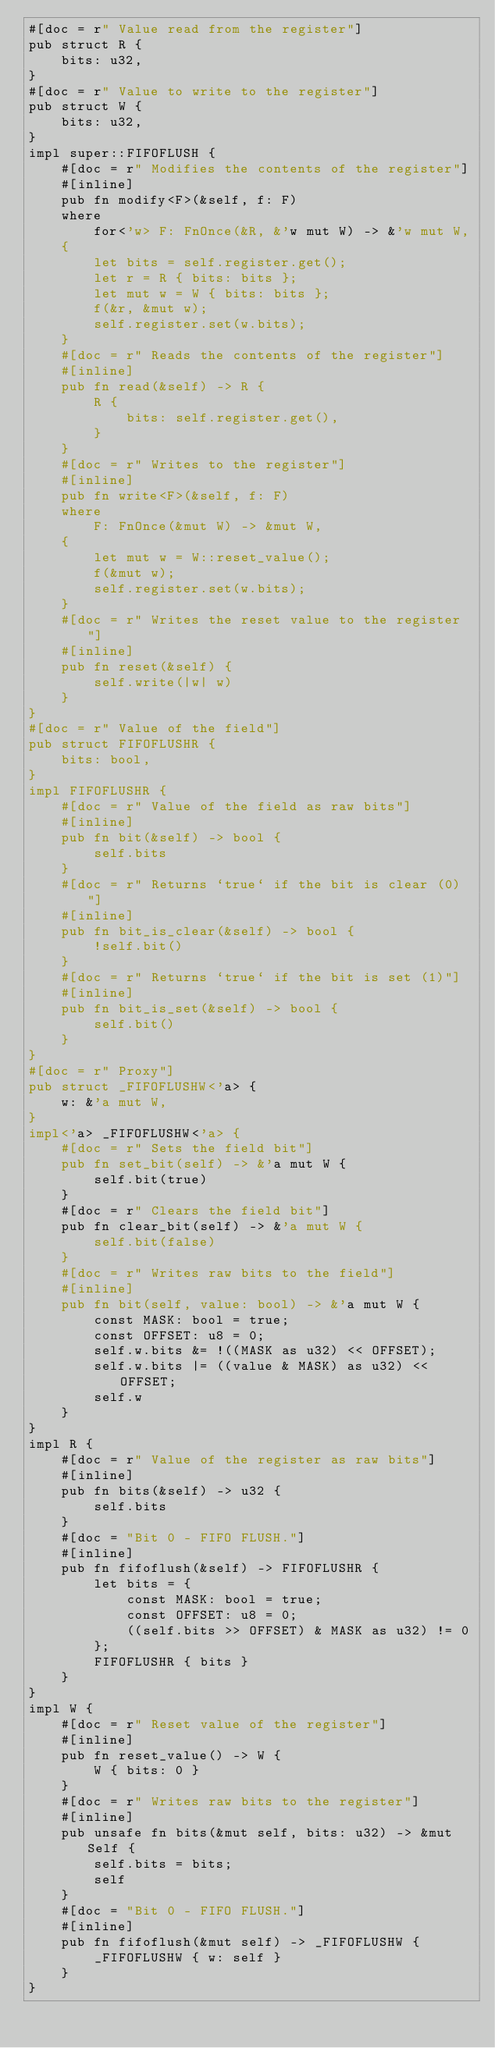Convert code to text. <code><loc_0><loc_0><loc_500><loc_500><_Rust_>#[doc = r" Value read from the register"]
pub struct R {
    bits: u32,
}
#[doc = r" Value to write to the register"]
pub struct W {
    bits: u32,
}
impl super::FIFOFLUSH {
    #[doc = r" Modifies the contents of the register"]
    #[inline]
    pub fn modify<F>(&self, f: F)
    where
        for<'w> F: FnOnce(&R, &'w mut W) -> &'w mut W,
    {
        let bits = self.register.get();
        let r = R { bits: bits };
        let mut w = W { bits: bits };
        f(&r, &mut w);
        self.register.set(w.bits);
    }
    #[doc = r" Reads the contents of the register"]
    #[inline]
    pub fn read(&self) -> R {
        R {
            bits: self.register.get(),
        }
    }
    #[doc = r" Writes to the register"]
    #[inline]
    pub fn write<F>(&self, f: F)
    where
        F: FnOnce(&mut W) -> &mut W,
    {
        let mut w = W::reset_value();
        f(&mut w);
        self.register.set(w.bits);
    }
    #[doc = r" Writes the reset value to the register"]
    #[inline]
    pub fn reset(&self) {
        self.write(|w| w)
    }
}
#[doc = r" Value of the field"]
pub struct FIFOFLUSHR {
    bits: bool,
}
impl FIFOFLUSHR {
    #[doc = r" Value of the field as raw bits"]
    #[inline]
    pub fn bit(&self) -> bool {
        self.bits
    }
    #[doc = r" Returns `true` if the bit is clear (0)"]
    #[inline]
    pub fn bit_is_clear(&self) -> bool {
        !self.bit()
    }
    #[doc = r" Returns `true` if the bit is set (1)"]
    #[inline]
    pub fn bit_is_set(&self) -> bool {
        self.bit()
    }
}
#[doc = r" Proxy"]
pub struct _FIFOFLUSHW<'a> {
    w: &'a mut W,
}
impl<'a> _FIFOFLUSHW<'a> {
    #[doc = r" Sets the field bit"]
    pub fn set_bit(self) -> &'a mut W {
        self.bit(true)
    }
    #[doc = r" Clears the field bit"]
    pub fn clear_bit(self) -> &'a mut W {
        self.bit(false)
    }
    #[doc = r" Writes raw bits to the field"]
    #[inline]
    pub fn bit(self, value: bool) -> &'a mut W {
        const MASK: bool = true;
        const OFFSET: u8 = 0;
        self.w.bits &= !((MASK as u32) << OFFSET);
        self.w.bits |= ((value & MASK) as u32) << OFFSET;
        self.w
    }
}
impl R {
    #[doc = r" Value of the register as raw bits"]
    #[inline]
    pub fn bits(&self) -> u32 {
        self.bits
    }
    #[doc = "Bit 0 - FIFO FLUSH."]
    #[inline]
    pub fn fifoflush(&self) -> FIFOFLUSHR {
        let bits = {
            const MASK: bool = true;
            const OFFSET: u8 = 0;
            ((self.bits >> OFFSET) & MASK as u32) != 0
        };
        FIFOFLUSHR { bits }
    }
}
impl W {
    #[doc = r" Reset value of the register"]
    #[inline]
    pub fn reset_value() -> W {
        W { bits: 0 }
    }
    #[doc = r" Writes raw bits to the register"]
    #[inline]
    pub unsafe fn bits(&mut self, bits: u32) -> &mut Self {
        self.bits = bits;
        self
    }
    #[doc = "Bit 0 - FIFO FLUSH."]
    #[inline]
    pub fn fifoflush(&mut self) -> _FIFOFLUSHW {
        _FIFOFLUSHW { w: self }
    }
}
</code> 